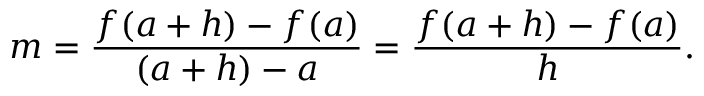<formula> <loc_0><loc_0><loc_500><loc_500>m = { \frac { f ( a + h ) - f ( a ) } { ( a + h ) - a } } = { \frac { f ( a + h ) - f ( a ) } { h } } .</formula> 